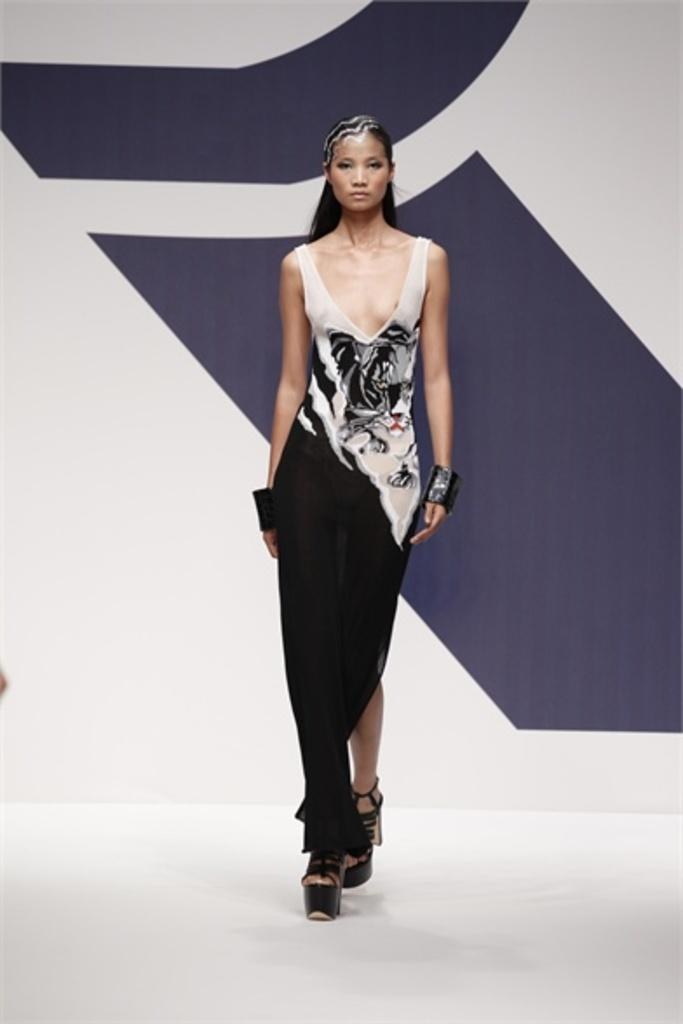Who is the main subject in the picture? There is a woman in the picture. What is the woman doing in the image? The woman is doing a ramp walk. What is the woman wearing in the picture? The woman is wearing a black and white dress and black heels. What type of cover is being distributed by the laborer in the image? There is no laborer or cover present in the image; it features a woman doing a ramp walk. 